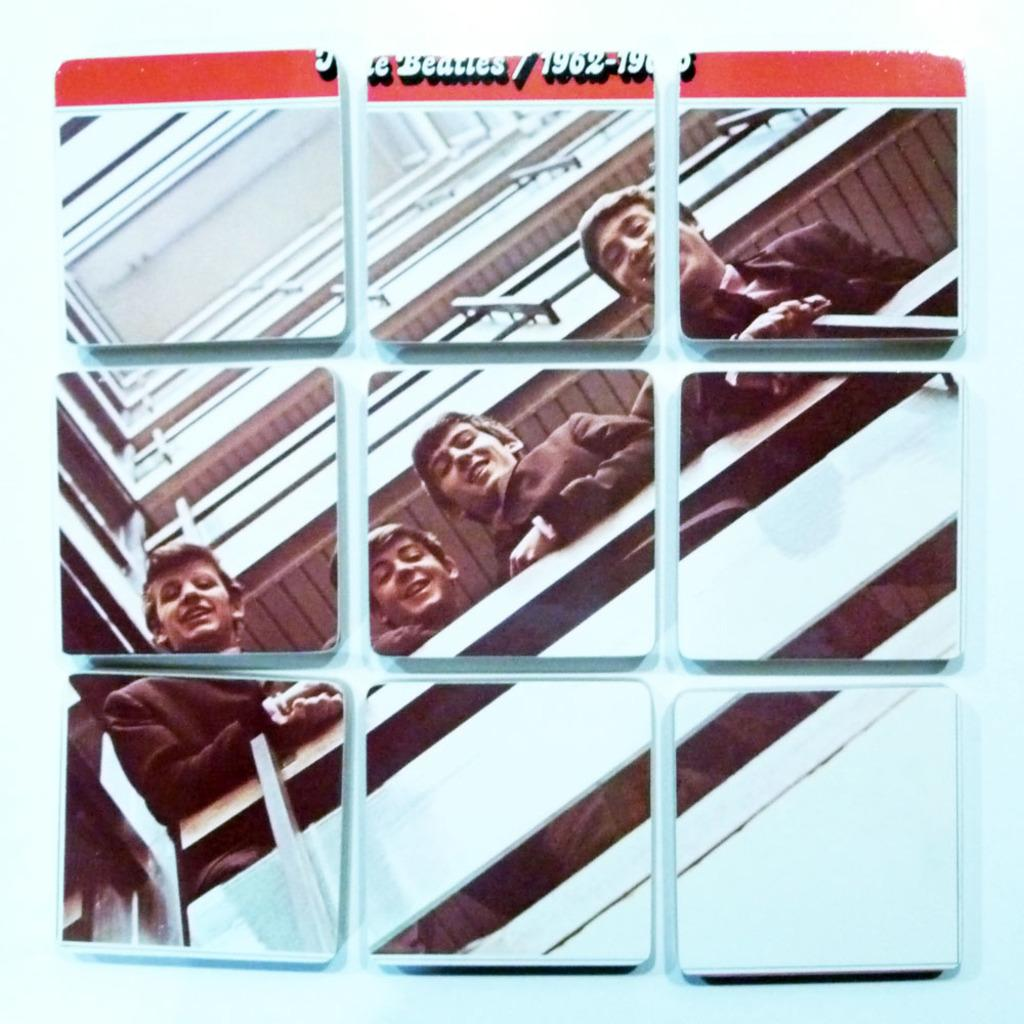What type of structure can be seen in the image? There is a building in the image. What is the purpose of the glass window in the image? The glass window allows us to see four people standing inside the building. Can you describe the text or writing visible at the top of the image? Unfortunately, the specific text or writing cannot be determined from the provided facts. How many people are visible through the glass window? Four people are standing and visible through the window. What type of nerve can be seen connecting the people in the image? There are no visible nerves connecting the people in the image; they are simply standing inside the building. What spark can be seen causing an effect on the building in the image? There is no spark or any other visible cause of an effect on the building in the image. 